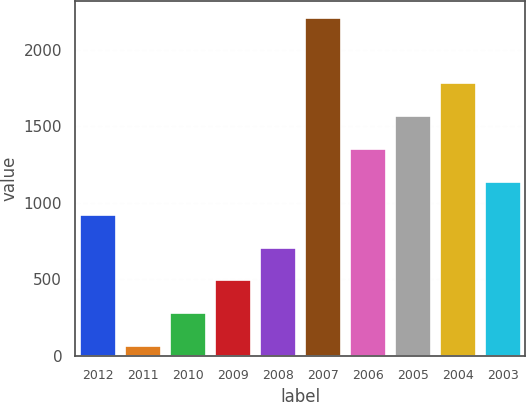Convert chart to OTSL. <chart><loc_0><loc_0><loc_500><loc_500><bar_chart><fcel>2012<fcel>2011<fcel>2010<fcel>2009<fcel>2008<fcel>2007<fcel>2006<fcel>2005<fcel>2004<fcel>2003<nl><fcel>922<fcel>64<fcel>278.5<fcel>493<fcel>707.5<fcel>2209<fcel>1351<fcel>1565.5<fcel>1780<fcel>1136.5<nl></chart> 